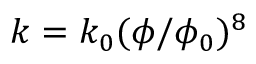<formula> <loc_0><loc_0><loc_500><loc_500>k = k _ { 0 } ( \phi / \phi _ { 0 } ) ^ { 8 }</formula> 